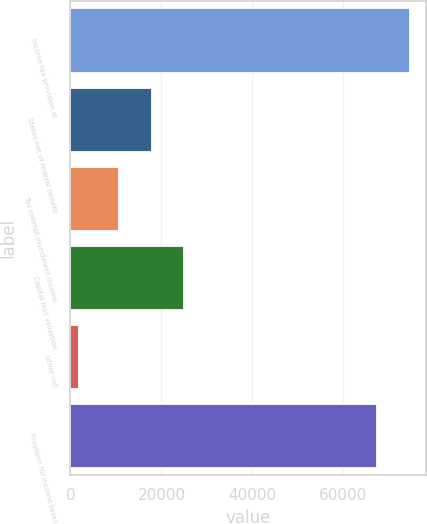<chart> <loc_0><loc_0><loc_500><loc_500><bar_chart><fcel>Income tax provision at<fcel>States net of federal benefit<fcel>Tax exempt investment income<fcel>Capital loss valuation<fcel>Other net<fcel>Provision for income taxes<nl><fcel>74368.9<fcel>17649.9<fcel>10460<fcel>24839.8<fcel>1578<fcel>67179<nl></chart> 